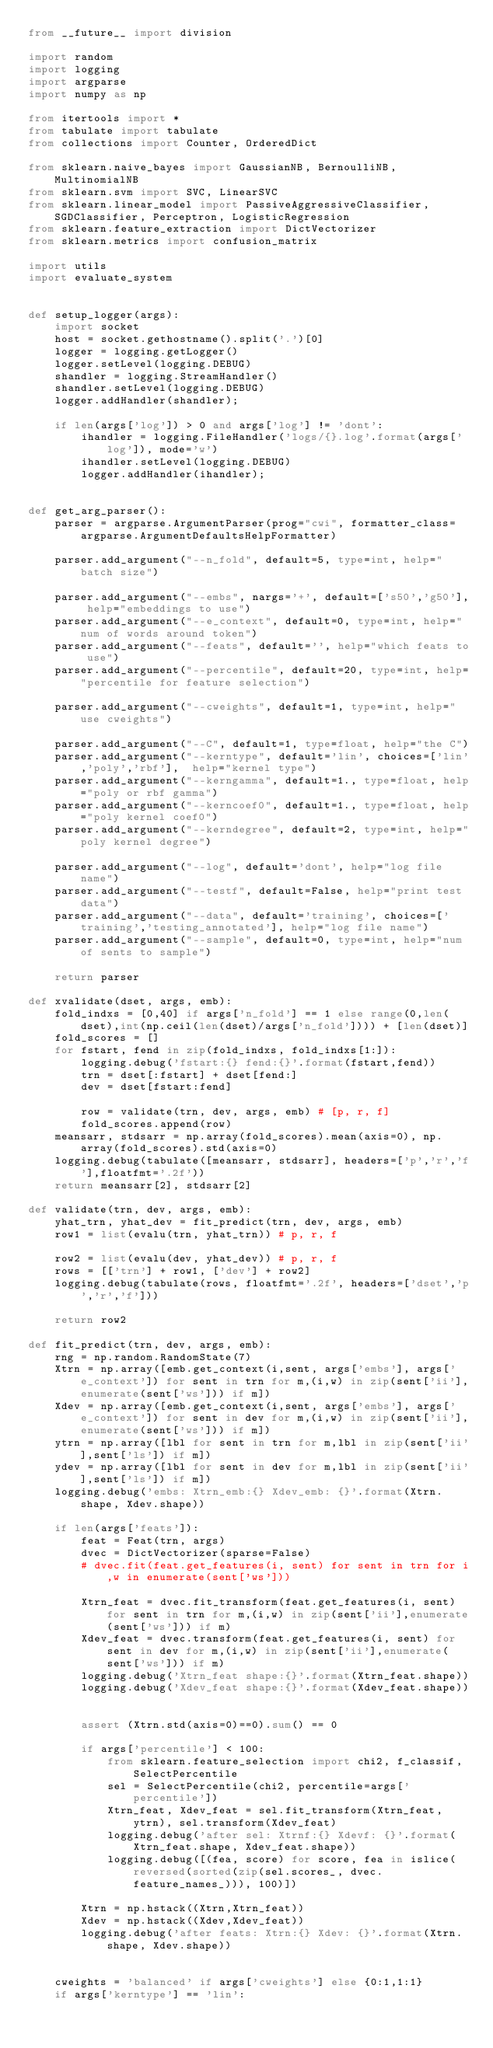<code> <loc_0><loc_0><loc_500><loc_500><_Python_>from __future__ import division

import random
import logging
import argparse
import numpy as np

from itertools import *
from tabulate import tabulate
from collections import Counter, OrderedDict

from sklearn.naive_bayes import GaussianNB, BernoulliNB, MultinomialNB
from sklearn.svm import SVC, LinearSVC
from sklearn.linear_model import PassiveAggressiveClassifier, SGDClassifier, Perceptron, LogisticRegression
from sklearn.feature_extraction import DictVectorizer
from sklearn.metrics import confusion_matrix

import utils
import evaluate_system


def setup_logger(args):
    import socket
    host = socket.gethostname().split('.')[0]
    logger = logging.getLogger()
    logger.setLevel(logging.DEBUG)
    shandler = logging.StreamHandler()
    shandler.setLevel(logging.DEBUG)
    logger.addHandler(shandler);

    if len(args['log']) > 0 and args['log'] != 'dont':
        ihandler = logging.FileHandler('logs/{}.log'.format(args['log']), mode='w')
        ihandler.setLevel(logging.DEBUG)
        logger.addHandler(ihandler);


def get_arg_parser():
    parser = argparse.ArgumentParser(prog="cwi", formatter_class=argparse.ArgumentDefaultsHelpFormatter)
    
    parser.add_argument("--n_fold", default=5, type=int, help="batch size")

    parser.add_argument("--embs", nargs='+', default=['s50','g50'], help="embeddings to use")
    parser.add_argument("--e_context", default=0, type=int, help="num of words around token")
    parser.add_argument("--feats", default='', help="which feats to use")
    parser.add_argument("--percentile", default=20, type=int, help="percentile for feature selection")

    parser.add_argument("--cweights", default=1, type=int, help="use cweights")

    parser.add_argument("--C", default=1, type=float, help="the C")
    parser.add_argument("--kerntype", default='lin', choices=['lin','poly','rbf'],  help="kernel type")
    parser.add_argument("--kerngamma", default=1., type=float, help="poly or rbf gamma")
    parser.add_argument("--kerncoef0", default=1., type=float, help="poly kernel coef0")
    parser.add_argument("--kerndegree", default=2, type=int, help="poly kernel degree")

    parser.add_argument("--log", default='dont', help="log file name")
    parser.add_argument("--testf", default=False, help="print test data")
    parser.add_argument("--data", default='training', choices=['training','testing_annotated'], help="log file name")
    parser.add_argument("--sample", default=0, type=int, help="num of sents to sample")

    return parser

def xvalidate(dset, args, emb):
    fold_indxs = [0,40] if args['n_fold'] == 1 else range(0,len(dset),int(np.ceil(len(dset)/args['n_fold']))) + [len(dset)]
    fold_scores = []
    for fstart, fend in zip(fold_indxs, fold_indxs[1:]):
        logging.debug('fstart:{} fend:{}'.format(fstart,fend))
        trn = dset[:fstart] + dset[fend:]
        dev = dset[fstart:fend]

        row = validate(trn, dev, args, emb) # [p, r, f]
        fold_scores.append(row)
    meansarr, stdsarr = np.array(fold_scores).mean(axis=0), np.array(fold_scores).std(axis=0)
    logging.debug(tabulate([meansarr, stdsarr], headers=['p','r','f'],floatfmt='.2f'))
    return meansarr[2], stdsarr[2]

def validate(trn, dev, args, emb):
    yhat_trn, yhat_dev = fit_predict(trn, dev, args, emb)
    row1 = list(evalu(trn, yhat_trn)) # p, r, f

    row2 = list(evalu(dev, yhat_dev)) # p, r, f
    rows = [['trn'] + row1, ['dev'] + row2]
    logging.debug(tabulate(rows, floatfmt='.2f', headers=['dset','p','r','f']))

    return row2

def fit_predict(trn, dev, args, emb):
    rng = np.random.RandomState(7)
    Xtrn = np.array([emb.get_context(i,sent, args['embs'], args['e_context']) for sent in trn for m,(i,w) in zip(sent['ii'],enumerate(sent['ws'])) if m])
    Xdev = np.array([emb.get_context(i,sent, args['embs'], args['e_context']) for sent in dev for m,(i,w) in zip(sent['ii'],enumerate(sent['ws'])) if m])
    ytrn = np.array([lbl for sent in trn for m,lbl in zip(sent['ii'],sent['ls']) if m])
    ydev = np.array([lbl for sent in dev for m,lbl in zip(sent['ii'],sent['ls']) if m])
    logging.debug('embs: Xtrn_emb:{} Xdev_emb: {}'.format(Xtrn.shape, Xdev.shape))

    if len(args['feats']):
        feat = Feat(trn, args)
        dvec = DictVectorizer(sparse=False)
        # dvec.fit(feat.get_features(i, sent) for sent in trn for i,w in enumerate(sent['ws']))

        Xtrn_feat = dvec.fit_transform(feat.get_features(i, sent) for sent in trn for m,(i,w) in zip(sent['ii'],enumerate(sent['ws'])) if m)
        Xdev_feat = dvec.transform(feat.get_features(i, sent) for sent in dev for m,(i,w) in zip(sent['ii'],enumerate(sent['ws'])) if m)
        logging.debug('Xtrn_feat shape:{}'.format(Xtrn_feat.shape))
        logging.debug('Xdev_feat shape:{}'.format(Xdev_feat.shape))


        assert (Xtrn.std(axis=0)==0).sum() == 0

        if args['percentile'] < 100:
            from sklearn.feature_selection import chi2, f_classif, SelectPercentile
            sel = SelectPercentile(chi2, percentile=args['percentile'])
            Xtrn_feat, Xdev_feat = sel.fit_transform(Xtrn_feat, ytrn), sel.transform(Xdev_feat)
            logging.debug('after sel: Xtrnf:{} Xdevf: {}'.format(Xtrn_feat.shape, Xdev_feat.shape))
            logging.debug([(fea, score) for score, fea in islice(reversed(sorted(zip(sel.scores_, dvec.feature_names_))), 100)])

        Xtrn = np.hstack((Xtrn,Xtrn_feat))
        Xdev = np.hstack((Xdev,Xdev_feat))
        logging.debug('after feats: Xtrn:{} Xdev: {}'.format(Xtrn.shape, Xdev.shape))


    cweights = 'balanced' if args['cweights'] else {0:1,1:1}
    if args['kerntype'] == 'lin':</code> 